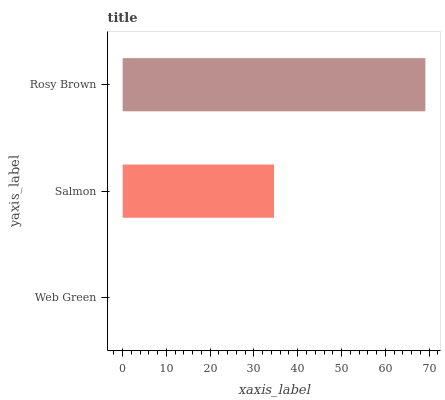Is Web Green the minimum?
Answer yes or no. Yes. Is Rosy Brown the maximum?
Answer yes or no. Yes. Is Salmon the minimum?
Answer yes or no. No. Is Salmon the maximum?
Answer yes or no. No. Is Salmon greater than Web Green?
Answer yes or no. Yes. Is Web Green less than Salmon?
Answer yes or no. Yes. Is Web Green greater than Salmon?
Answer yes or no. No. Is Salmon less than Web Green?
Answer yes or no. No. Is Salmon the high median?
Answer yes or no. Yes. Is Salmon the low median?
Answer yes or no. Yes. Is Rosy Brown the high median?
Answer yes or no. No. Is Rosy Brown the low median?
Answer yes or no. No. 